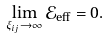<formula> <loc_0><loc_0><loc_500><loc_500>\lim _ { \xi _ { i j } \to \infty } \mathcal { E } _ { \text {eff} } = 0 .</formula> 